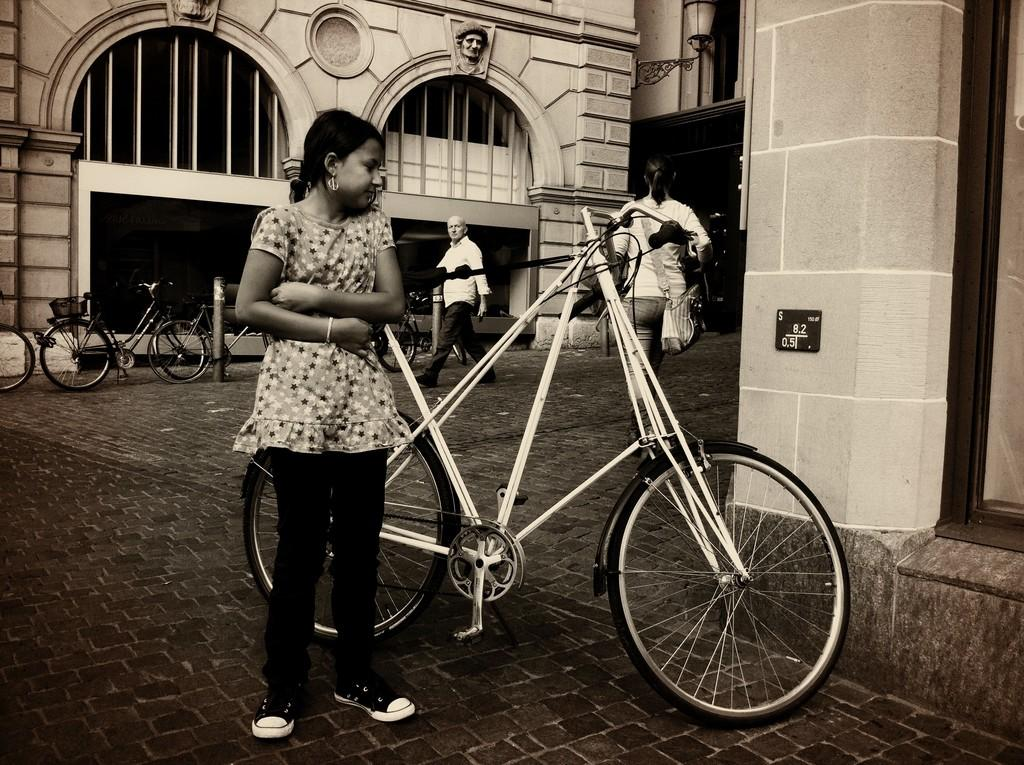What is the color scheme of the image? The image is in black and white. What can be seen in the foreground of the image? There is a girl standing in the image. What is located behind the girl in the image? Bicycles are present behind the girl. What is happening on the road in the image? There are persons walking on the road in the image. What type of structures can be seen in the image? Buildings are visible in the image. What type of bridge can be seen in the image? There is no bridge present in the image. What letters are visible on the buildings in the image? There is no indication of letters or text on the buildings in the image. 